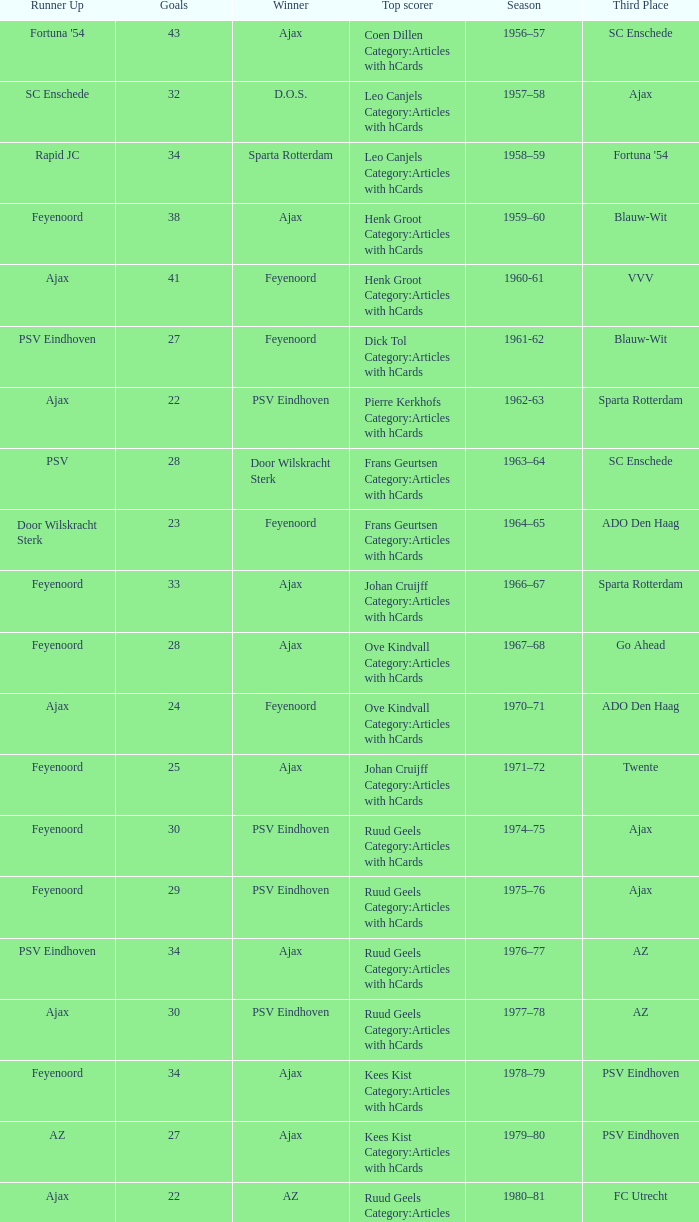When az is the runner up nad feyenoord came in third place how many overall winners are there? 1.0. 